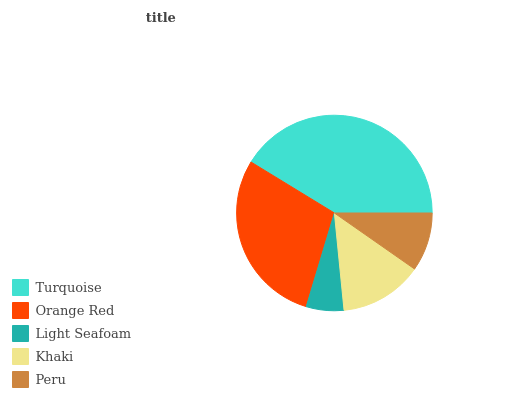Is Light Seafoam the minimum?
Answer yes or no. Yes. Is Turquoise the maximum?
Answer yes or no. Yes. Is Orange Red the minimum?
Answer yes or no. No. Is Orange Red the maximum?
Answer yes or no. No. Is Turquoise greater than Orange Red?
Answer yes or no. Yes. Is Orange Red less than Turquoise?
Answer yes or no. Yes. Is Orange Red greater than Turquoise?
Answer yes or no. No. Is Turquoise less than Orange Red?
Answer yes or no. No. Is Khaki the high median?
Answer yes or no. Yes. Is Khaki the low median?
Answer yes or no. Yes. Is Light Seafoam the high median?
Answer yes or no. No. Is Light Seafoam the low median?
Answer yes or no. No. 